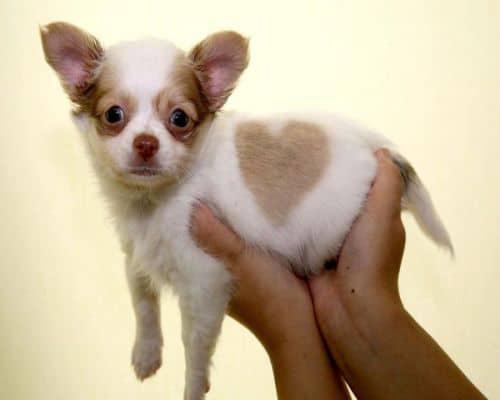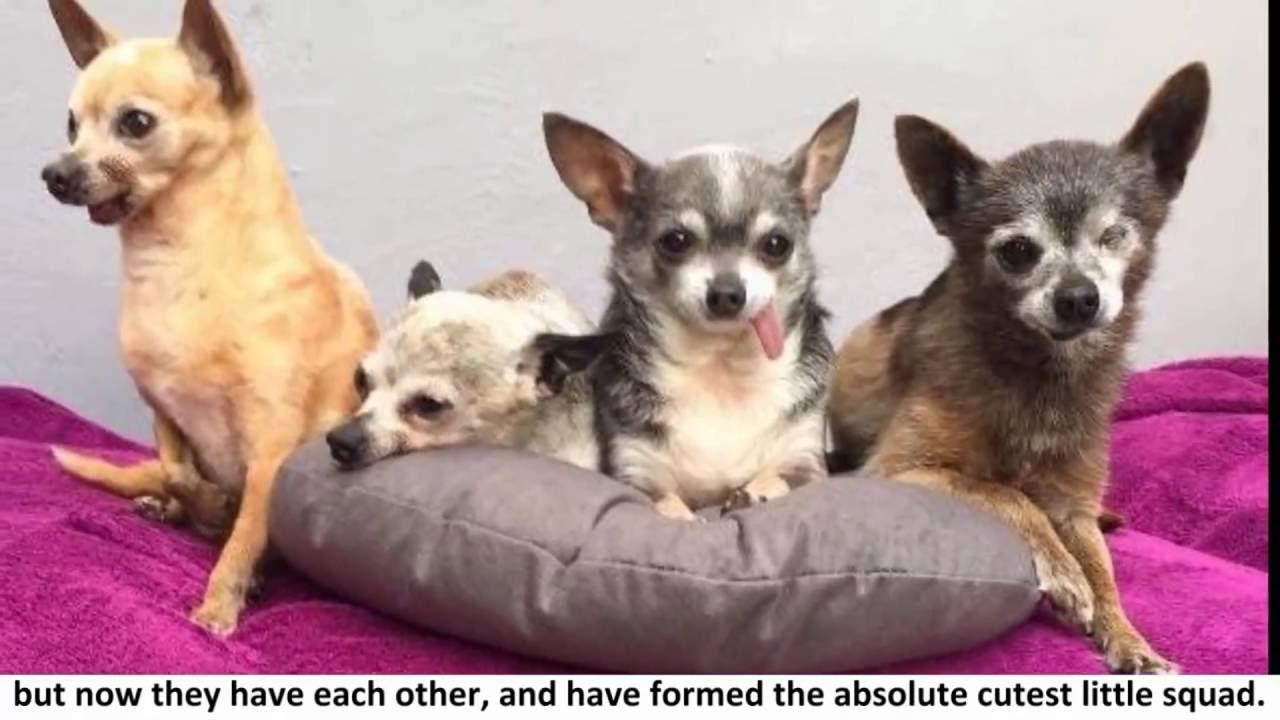The first image is the image on the left, the second image is the image on the right. Analyze the images presented: Is the assertion "There are at least five chihuahuas." valid? Answer yes or no. Yes. The first image is the image on the left, the second image is the image on the right. Assess this claim about the two images: "The images show five dogs.". Correct or not? Answer yes or no. Yes. 